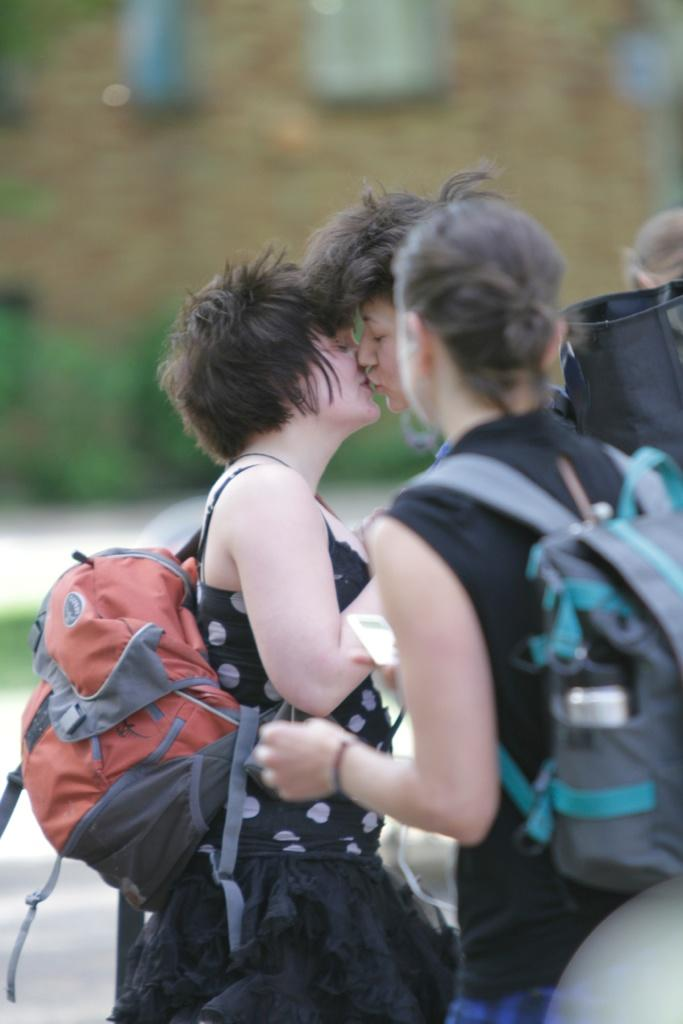Where was the image taken? The image was taken outdoors. What is happening in the image? There is a group of people in the image. What are the people wearing? The people are wearing bags. What is the surface the people are standing on? The people are standing on the floor. What can be seen in the background of the image? There is a building in the background of the image. What type of humor can be seen in the image? There is no humor present in the image; it simply shows a group of people wearing bags and standing on the floor. What sense is being conveyed by the image? The image does not convey a specific sense; it is a straightforward depiction of a group of people wearing bags and standing on the floor. 